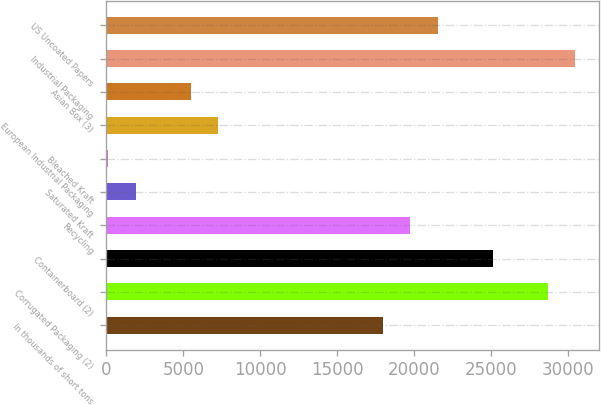Convert chart. <chart><loc_0><loc_0><loc_500><loc_500><bar_chart><fcel>In thousands of short tons<fcel>Corrugated Packaging (2)<fcel>Containerboard (2)<fcel>Recycling<fcel>Saturated Kraft<fcel>Bleached Kraft<fcel>European Industrial Packaging<fcel>Asian Box (3)<fcel>Industrial Packaging<fcel>US Uncoated Papers<nl><fcel>17957<fcel>28662.8<fcel>25094.2<fcel>19741.3<fcel>1898.3<fcel>114<fcel>7251.2<fcel>5466.9<fcel>30447.1<fcel>21525.6<nl></chart> 